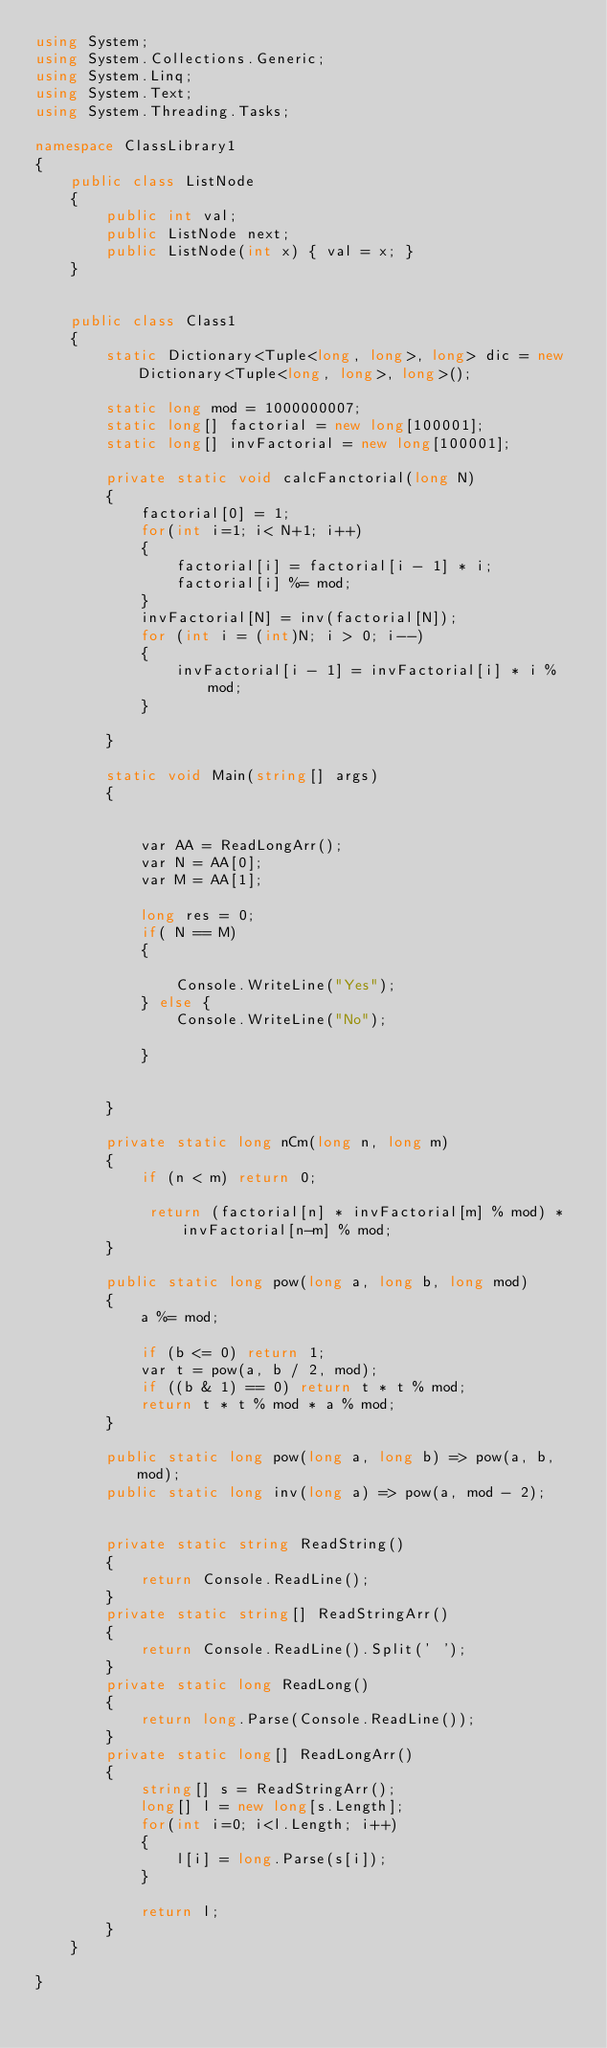Convert code to text. <code><loc_0><loc_0><loc_500><loc_500><_C#_>using System;
using System.Collections.Generic;
using System.Linq;
using System.Text;
using System.Threading.Tasks;

namespace ClassLibrary1
{
    public class ListNode
    {
        public int val;
        public ListNode next;
        public ListNode(int x) { val = x; }
    }


    public class Class1
    {
        static Dictionary<Tuple<long, long>, long> dic = new Dictionary<Tuple<long, long>, long>();

        static long mod = 1000000007;
        static long[] factorial = new long[100001];
        static long[] invFactorial = new long[100001];

        private static void calcFanctorial(long N)
        {
            factorial[0] = 1;
            for(int i=1; i< N+1; i++)
            {
                factorial[i] = factorial[i - 1] * i;
                factorial[i] %= mod;
            }
            invFactorial[N] = inv(factorial[N]);
            for (int i = (int)N; i > 0; i--)
            {
                invFactorial[i - 1] = invFactorial[i] * i % mod;
            }

        }

        static void Main(string[] args)
        {


            var AA = ReadLongArr();
            var N = AA[0];
            var M = AA[1];

            long res = 0;
            if( N == M)
            {

                Console.WriteLine("Yes");
            } else {
                Console.WriteLine("No");

            }


        }

        private static long nCm(long n, long m)
        {
            if (n < m) return 0;

             return (factorial[n] * invFactorial[m] % mod) * invFactorial[n-m] % mod;
        }

        public static long pow(long a, long b, long mod)
        {
            a %= mod;

            if (b <= 0) return 1;
            var t = pow(a, b / 2, mod);
            if ((b & 1) == 0) return t * t % mod;
            return t * t % mod * a % mod;
        }

        public static long pow(long a, long b) => pow(a, b, mod);
        public static long inv(long a) => pow(a, mod - 2);


        private static string ReadString()
        {
            return Console.ReadLine();
        }
        private static string[] ReadStringArr()
        {
            return Console.ReadLine().Split(' ');
        }
        private static long ReadLong()
        {
            return long.Parse(Console.ReadLine());
        }
        private static long[] ReadLongArr()
        {
            string[] s = ReadStringArr();
            long[] l = new long[s.Length];
            for(int i=0; i<l.Length; i++)
            {
                l[i] = long.Parse(s[i]);
            }

            return l;
        }
    }

}
</code> 